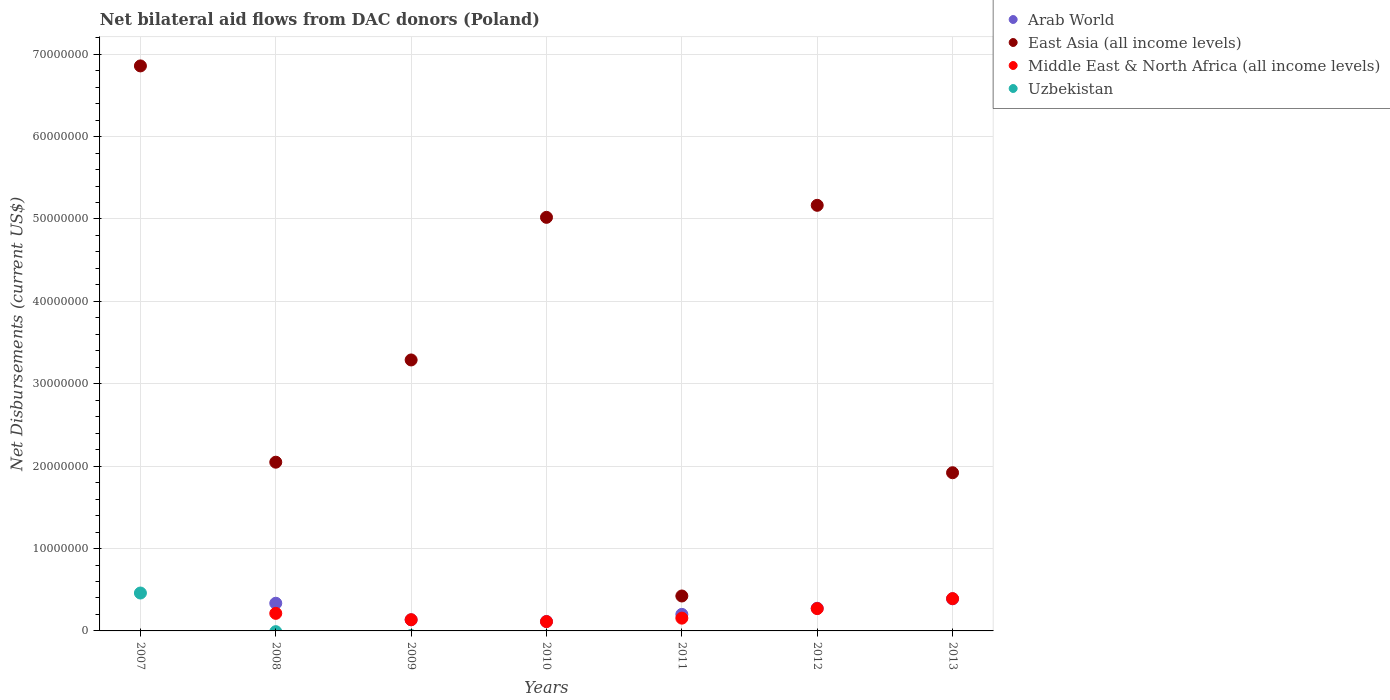How many different coloured dotlines are there?
Give a very brief answer. 4. What is the net bilateral aid flows in Arab World in 2010?
Your answer should be compact. 1.15e+06. Across all years, what is the maximum net bilateral aid flows in East Asia (all income levels)?
Give a very brief answer. 6.86e+07. Across all years, what is the minimum net bilateral aid flows in East Asia (all income levels)?
Make the answer very short. 4.24e+06. In which year was the net bilateral aid flows in Arab World maximum?
Make the answer very short. 2013. What is the total net bilateral aid flows in Middle East & North Africa (all income levels) in the graph?
Your answer should be very brief. 1.28e+07. What is the difference between the net bilateral aid flows in East Asia (all income levels) in 2008 and that in 2013?
Your response must be concise. 1.28e+06. What is the difference between the net bilateral aid flows in Arab World in 2012 and the net bilateral aid flows in Uzbekistan in 2008?
Offer a terse response. 2.75e+06. What is the average net bilateral aid flows in Middle East & North Africa (all income levels) per year?
Offer a very short reply. 1.83e+06. In the year 2007, what is the difference between the net bilateral aid flows in East Asia (all income levels) and net bilateral aid flows in Uzbekistan?
Make the answer very short. 6.40e+07. In how many years, is the net bilateral aid flows in Middle East & North Africa (all income levels) greater than 30000000 US$?
Provide a short and direct response. 0. What is the ratio of the net bilateral aid flows in East Asia (all income levels) in 2007 to that in 2010?
Your answer should be very brief. 1.37. Is the net bilateral aid flows in Middle East & North Africa (all income levels) in 2009 less than that in 2012?
Offer a terse response. Yes. What is the difference between the highest and the second highest net bilateral aid flows in Arab World?
Keep it short and to the point. 5.40e+05. What is the difference between the highest and the lowest net bilateral aid flows in Uzbekistan?
Your answer should be compact. 4.60e+06. Is it the case that in every year, the sum of the net bilateral aid flows in East Asia (all income levels) and net bilateral aid flows in Arab World  is greater than the sum of net bilateral aid flows in Middle East & North Africa (all income levels) and net bilateral aid flows in Uzbekistan?
Offer a terse response. Yes. Is the net bilateral aid flows in Arab World strictly less than the net bilateral aid flows in East Asia (all income levels) over the years?
Give a very brief answer. Yes. How many years are there in the graph?
Give a very brief answer. 7. What is the difference between two consecutive major ticks on the Y-axis?
Your answer should be very brief. 1.00e+07. Does the graph contain any zero values?
Provide a short and direct response. Yes. How many legend labels are there?
Make the answer very short. 4. What is the title of the graph?
Provide a short and direct response. Net bilateral aid flows from DAC donors (Poland). What is the label or title of the Y-axis?
Offer a terse response. Net Disbursements (current US$). What is the Net Disbursements (current US$) in East Asia (all income levels) in 2007?
Provide a short and direct response. 6.86e+07. What is the Net Disbursements (current US$) in Uzbekistan in 2007?
Ensure brevity in your answer.  4.60e+06. What is the Net Disbursements (current US$) in Arab World in 2008?
Your answer should be very brief. 3.36e+06. What is the Net Disbursements (current US$) of East Asia (all income levels) in 2008?
Make the answer very short. 2.05e+07. What is the Net Disbursements (current US$) of Middle East & North Africa (all income levels) in 2008?
Make the answer very short. 2.13e+06. What is the Net Disbursements (current US$) of Uzbekistan in 2008?
Give a very brief answer. 0. What is the Net Disbursements (current US$) of Arab World in 2009?
Offer a terse response. 1.35e+06. What is the Net Disbursements (current US$) in East Asia (all income levels) in 2009?
Your answer should be compact. 3.29e+07. What is the Net Disbursements (current US$) of Middle East & North Africa (all income levels) in 2009?
Give a very brief answer. 1.36e+06. What is the Net Disbursements (current US$) of Uzbekistan in 2009?
Your response must be concise. 0. What is the Net Disbursements (current US$) of Arab World in 2010?
Your answer should be compact. 1.15e+06. What is the Net Disbursements (current US$) in East Asia (all income levels) in 2010?
Offer a terse response. 5.02e+07. What is the Net Disbursements (current US$) in Middle East & North Africa (all income levels) in 2010?
Your response must be concise. 1.13e+06. What is the Net Disbursements (current US$) in Uzbekistan in 2010?
Keep it short and to the point. 0. What is the Net Disbursements (current US$) of Arab World in 2011?
Provide a short and direct response. 2.01e+06. What is the Net Disbursements (current US$) in East Asia (all income levels) in 2011?
Your answer should be compact. 4.24e+06. What is the Net Disbursements (current US$) of Middle East & North Africa (all income levels) in 2011?
Provide a succinct answer. 1.55e+06. What is the Net Disbursements (current US$) in Arab World in 2012?
Offer a very short reply. 2.75e+06. What is the Net Disbursements (current US$) of East Asia (all income levels) in 2012?
Keep it short and to the point. 5.17e+07. What is the Net Disbursements (current US$) of Middle East & North Africa (all income levels) in 2012?
Ensure brevity in your answer.  2.71e+06. What is the Net Disbursements (current US$) of Arab World in 2013?
Your answer should be compact. 3.90e+06. What is the Net Disbursements (current US$) of East Asia (all income levels) in 2013?
Your answer should be compact. 1.92e+07. What is the Net Disbursements (current US$) of Middle East & North Africa (all income levels) in 2013?
Your answer should be compact. 3.92e+06. What is the Net Disbursements (current US$) in Uzbekistan in 2013?
Your answer should be compact. 0. Across all years, what is the maximum Net Disbursements (current US$) in Arab World?
Your response must be concise. 3.90e+06. Across all years, what is the maximum Net Disbursements (current US$) in East Asia (all income levels)?
Offer a terse response. 6.86e+07. Across all years, what is the maximum Net Disbursements (current US$) in Middle East & North Africa (all income levels)?
Your answer should be compact. 3.92e+06. Across all years, what is the maximum Net Disbursements (current US$) of Uzbekistan?
Make the answer very short. 4.60e+06. Across all years, what is the minimum Net Disbursements (current US$) of Arab World?
Provide a succinct answer. 0. Across all years, what is the minimum Net Disbursements (current US$) of East Asia (all income levels)?
Your answer should be very brief. 4.24e+06. Across all years, what is the minimum Net Disbursements (current US$) in Middle East & North Africa (all income levels)?
Give a very brief answer. 0. Across all years, what is the minimum Net Disbursements (current US$) of Uzbekistan?
Keep it short and to the point. 0. What is the total Net Disbursements (current US$) in Arab World in the graph?
Your response must be concise. 1.45e+07. What is the total Net Disbursements (current US$) in East Asia (all income levels) in the graph?
Make the answer very short. 2.47e+08. What is the total Net Disbursements (current US$) in Middle East & North Africa (all income levels) in the graph?
Provide a short and direct response. 1.28e+07. What is the total Net Disbursements (current US$) in Uzbekistan in the graph?
Make the answer very short. 4.60e+06. What is the difference between the Net Disbursements (current US$) in East Asia (all income levels) in 2007 and that in 2008?
Ensure brevity in your answer.  4.81e+07. What is the difference between the Net Disbursements (current US$) in East Asia (all income levels) in 2007 and that in 2009?
Give a very brief answer. 3.57e+07. What is the difference between the Net Disbursements (current US$) in East Asia (all income levels) in 2007 and that in 2010?
Keep it short and to the point. 1.84e+07. What is the difference between the Net Disbursements (current US$) in East Asia (all income levels) in 2007 and that in 2011?
Your answer should be compact. 6.43e+07. What is the difference between the Net Disbursements (current US$) of East Asia (all income levels) in 2007 and that in 2012?
Your answer should be very brief. 1.69e+07. What is the difference between the Net Disbursements (current US$) in East Asia (all income levels) in 2007 and that in 2013?
Your answer should be compact. 4.94e+07. What is the difference between the Net Disbursements (current US$) of Arab World in 2008 and that in 2009?
Ensure brevity in your answer.  2.01e+06. What is the difference between the Net Disbursements (current US$) in East Asia (all income levels) in 2008 and that in 2009?
Your response must be concise. -1.24e+07. What is the difference between the Net Disbursements (current US$) in Middle East & North Africa (all income levels) in 2008 and that in 2009?
Your answer should be very brief. 7.70e+05. What is the difference between the Net Disbursements (current US$) of Arab World in 2008 and that in 2010?
Offer a terse response. 2.21e+06. What is the difference between the Net Disbursements (current US$) in East Asia (all income levels) in 2008 and that in 2010?
Keep it short and to the point. -2.97e+07. What is the difference between the Net Disbursements (current US$) of Arab World in 2008 and that in 2011?
Give a very brief answer. 1.35e+06. What is the difference between the Net Disbursements (current US$) of East Asia (all income levels) in 2008 and that in 2011?
Provide a succinct answer. 1.62e+07. What is the difference between the Net Disbursements (current US$) of Middle East & North Africa (all income levels) in 2008 and that in 2011?
Make the answer very short. 5.80e+05. What is the difference between the Net Disbursements (current US$) in Arab World in 2008 and that in 2012?
Provide a short and direct response. 6.10e+05. What is the difference between the Net Disbursements (current US$) in East Asia (all income levels) in 2008 and that in 2012?
Keep it short and to the point. -3.12e+07. What is the difference between the Net Disbursements (current US$) of Middle East & North Africa (all income levels) in 2008 and that in 2012?
Give a very brief answer. -5.80e+05. What is the difference between the Net Disbursements (current US$) of Arab World in 2008 and that in 2013?
Your answer should be compact. -5.40e+05. What is the difference between the Net Disbursements (current US$) in East Asia (all income levels) in 2008 and that in 2013?
Give a very brief answer. 1.28e+06. What is the difference between the Net Disbursements (current US$) in Middle East & North Africa (all income levels) in 2008 and that in 2013?
Provide a succinct answer. -1.79e+06. What is the difference between the Net Disbursements (current US$) in Arab World in 2009 and that in 2010?
Provide a succinct answer. 2.00e+05. What is the difference between the Net Disbursements (current US$) of East Asia (all income levels) in 2009 and that in 2010?
Give a very brief answer. -1.73e+07. What is the difference between the Net Disbursements (current US$) in Middle East & North Africa (all income levels) in 2009 and that in 2010?
Offer a very short reply. 2.30e+05. What is the difference between the Net Disbursements (current US$) in Arab World in 2009 and that in 2011?
Your response must be concise. -6.60e+05. What is the difference between the Net Disbursements (current US$) of East Asia (all income levels) in 2009 and that in 2011?
Make the answer very short. 2.86e+07. What is the difference between the Net Disbursements (current US$) in Arab World in 2009 and that in 2012?
Make the answer very short. -1.40e+06. What is the difference between the Net Disbursements (current US$) of East Asia (all income levels) in 2009 and that in 2012?
Your answer should be very brief. -1.88e+07. What is the difference between the Net Disbursements (current US$) in Middle East & North Africa (all income levels) in 2009 and that in 2012?
Offer a very short reply. -1.35e+06. What is the difference between the Net Disbursements (current US$) of Arab World in 2009 and that in 2013?
Your answer should be compact. -2.55e+06. What is the difference between the Net Disbursements (current US$) of East Asia (all income levels) in 2009 and that in 2013?
Your answer should be very brief. 1.37e+07. What is the difference between the Net Disbursements (current US$) in Middle East & North Africa (all income levels) in 2009 and that in 2013?
Provide a succinct answer. -2.56e+06. What is the difference between the Net Disbursements (current US$) in Arab World in 2010 and that in 2011?
Your response must be concise. -8.60e+05. What is the difference between the Net Disbursements (current US$) of East Asia (all income levels) in 2010 and that in 2011?
Your response must be concise. 4.60e+07. What is the difference between the Net Disbursements (current US$) in Middle East & North Africa (all income levels) in 2010 and that in 2011?
Give a very brief answer. -4.20e+05. What is the difference between the Net Disbursements (current US$) of Arab World in 2010 and that in 2012?
Your answer should be very brief. -1.60e+06. What is the difference between the Net Disbursements (current US$) of East Asia (all income levels) in 2010 and that in 2012?
Provide a succinct answer. -1.46e+06. What is the difference between the Net Disbursements (current US$) of Middle East & North Africa (all income levels) in 2010 and that in 2012?
Make the answer very short. -1.58e+06. What is the difference between the Net Disbursements (current US$) in Arab World in 2010 and that in 2013?
Keep it short and to the point. -2.75e+06. What is the difference between the Net Disbursements (current US$) of East Asia (all income levels) in 2010 and that in 2013?
Offer a terse response. 3.10e+07. What is the difference between the Net Disbursements (current US$) in Middle East & North Africa (all income levels) in 2010 and that in 2013?
Give a very brief answer. -2.79e+06. What is the difference between the Net Disbursements (current US$) of Arab World in 2011 and that in 2012?
Your answer should be compact. -7.40e+05. What is the difference between the Net Disbursements (current US$) in East Asia (all income levels) in 2011 and that in 2012?
Keep it short and to the point. -4.74e+07. What is the difference between the Net Disbursements (current US$) of Middle East & North Africa (all income levels) in 2011 and that in 2012?
Your answer should be very brief. -1.16e+06. What is the difference between the Net Disbursements (current US$) in Arab World in 2011 and that in 2013?
Offer a terse response. -1.89e+06. What is the difference between the Net Disbursements (current US$) in East Asia (all income levels) in 2011 and that in 2013?
Offer a very short reply. -1.50e+07. What is the difference between the Net Disbursements (current US$) in Middle East & North Africa (all income levels) in 2011 and that in 2013?
Ensure brevity in your answer.  -2.37e+06. What is the difference between the Net Disbursements (current US$) in Arab World in 2012 and that in 2013?
Keep it short and to the point. -1.15e+06. What is the difference between the Net Disbursements (current US$) of East Asia (all income levels) in 2012 and that in 2013?
Offer a terse response. 3.25e+07. What is the difference between the Net Disbursements (current US$) of Middle East & North Africa (all income levels) in 2012 and that in 2013?
Provide a short and direct response. -1.21e+06. What is the difference between the Net Disbursements (current US$) of East Asia (all income levels) in 2007 and the Net Disbursements (current US$) of Middle East & North Africa (all income levels) in 2008?
Make the answer very short. 6.64e+07. What is the difference between the Net Disbursements (current US$) of East Asia (all income levels) in 2007 and the Net Disbursements (current US$) of Middle East & North Africa (all income levels) in 2009?
Your answer should be very brief. 6.72e+07. What is the difference between the Net Disbursements (current US$) in East Asia (all income levels) in 2007 and the Net Disbursements (current US$) in Middle East & North Africa (all income levels) in 2010?
Ensure brevity in your answer.  6.74e+07. What is the difference between the Net Disbursements (current US$) of East Asia (all income levels) in 2007 and the Net Disbursements (current US$) of Middle East & North Africa (all income levels) in 2011?
Your response must be concise. 6.70e+07. What is the difference between the Net Disbursements (current US$) in East Asia (all income levels) in 2007 and the Net Disbursements (current US$) in Middle East & North Africa (all income levels) in 2012?
Make the answer very short. 6.59e+07. What is the difference between the Net Disbursements (current US$) in East Asia (all income levels) in 2007 and the Net Disbursements (current US$) in Middle East & North Africa (all income levels) in 2013?
Your response must be concise. 6.47e+07. What is the difference between the Net Disbursements (current US$) of Arab World in 2008 and the Net Disbursements (current US$) of East Asia (all income levels) in 2009?
Offer a terse response. -2.95e+07. What is the difference between the Net Disbursements (current US$) in East Asia (all income levels) in 2008 and the Net Disbursements (current US$) in Middle East & North Africa (all income levels) in 2009?
Provide a short and direct response. 1.91e+07. What is the difference between the Net Disbursements (current US$) in Arab World in 2008 and the Net Disbursements (current US$) in East Asia (all income levels) in 2010?
Ensure brevity in your answer.  -4.68e+07. What is the difference between the Net Disbursements (current US$) in Arab World in 2008 and the Net Disbursements (current US$) in Middle East & North Africa (all income levels) in 2010?
Keep it short and to the point. 2.23e+06. What is the difference between the Net Disbursements (current US$) of East Asia (all income levels) in 2008 and the Net Disbursements (current US$) of Middle East & North Africa (all income levels) in 2010?
Give a very brief answer. 1.94e+07. What is the difference between the Net Disbursements (current US$) of Arab World in 2008 and the Net Disbursements (current US$) of East Asia (all income levels) in 2011?
Provide a succinct answer. -8.80e+05. What is the difference between the Net Disbursements (current US$) in Arab World in 2008 and the Net Disbursements (current US$) in Middle East & North Africa (all income levels) in 2011?
Provide a short and direct response. 1.81e+06. What is the difference between the Net Disbursements (current US$) in East Asia (all income levels) in 2008 and the Net Disbursements (current US$) in Middle East & North Africa (all income levels) in 2011?
Ensure brevity in your answer.  1.89e+07. What is the difference between the Net Disbursements (current US$) in Arab World in 2008 and the Net Disbursements (current US$) in East Asia (all income levels) in 2012?
Give a very brief answer. -4.83e+07. What is the difference between the Net Disbursements (current US$) in Arab World in 2008 and the Net Disbursements (current US$) in Middle East & North Africa (all income levels) in 2012?
Give a very brief answer. 6.50e+05. What is the difference between the Net Disbursements (current US$) of East Asia (all income levels) in 2008 and the Net Disbursements (current US$) of Middle East & North Africa (all income levels) in 2012?
Offer a very short reply. 1.78e+07. What is the difference between the Net Disbursements (current US$) in Arab World in 2008 and the Net Disbursements (current US$) in East Asia (all income levels) in 2013?
Make the answer very short. -1.58e+07. What is the difference between the Net Disbursements (current US$) in Arab World in 2008 and the Net Disbursements (current US$) in Middle East & North Africa (all income levels) in 2013?
Offer a terse response. -5.60e+05. What is the difference between the Net Disbursements (current US$) of East Asia (all income levels) in 2008 and the Net Disbursements (current US$) of Middle East & North Africa (all income levels) in 2013?
Offer a very short reply. 1.66e+07. What is the difference between the Net Disbursements (current US$) in Arab World in 2009 and the Net Disbursements (current US$) in East Asia (all income levels) in 2010?
Ensure brevity in your answer.  -4.88e+07. What is the difference between the Net Disbursements (current US$) in East Asia (all income levels) in 2009 and the Net Disbursements (current US$) in Middle East & North Africa (all income levels) in 2010?
Your response must be concise. 3.18e+07. What is the difference between the Net Disbursements (current US$) of Arab World in 2009 and the Net Disbursements (current US$) of East Asia (all income levels) in 2011?
Your answer should be very brief. -2.89e+06. What is the difference between the Net Disbursements (current US$) in Arab World in 2009 and the Net Disbursements (current US$) in Middle East & North Africa (all income levels) in 2011?
Make the answer very short. -2.00e+05. What is the difference between the Net Disbursements (current US$) in East Asia (all income levels) in 2009 and the Net Disbursements (current US$) in Middle East & North Africa (all income levels) in 2011?
Give a very brief answer. 3.13e+07. What is the difference between the Net Disbursements (current US$) in Arab World in 2009 and the Net Disbursements (current US$) in East Asia (all income levels) in 2012?
Provide a succinct answer. -5.03e+07. What is the difference between the Net Disbursements (current US$) in Arab World in 2009 and the Net Disbursements (current US$) in Middle East & North Africa (all income levels) in 2012?
Offer a terse response. -1.36e+06. What is the difference between the Net Disbursements (current US$) of East Asia (all income levels) in 2009 and the Net Disbursements (current US$) of Middle East & North Africa (all income levels) in 2012?
Provide a succinct answer. 3.02e+07. What is the difference between the Net Disbursements (current US$) of Arab World in 2009 and the Net Disbursements (current US$) of East Asia (all income levels) in 2013?
Provide a short and direct response. -1.78e+07. What is the difference between the Net Disbursements (current US$) in Arab World in 2009 and the Net Disbursements (current US$) in Middle East & North Africa (all income levels) in 2013?
Provide a succinct answer. -2.57e+06. What is the difference between the Net Disbursements (current US$) of East Asia (all income levels) in 2009 and the Net Disbursements (current US$) of Middle East & North Africa (all income levels) in 2013?
Provide a succinct answer. 2.90e+07. What is the difference between the Net Disbursements (current US$) of Arab World in 2010 and the Net Disbursements (current US$) of East Asia (all income levels) in 2011?
Provide a succinct answer. -3.09e+06. What is the difference between the Net Disbursements (current US$) of Arab World in 2010 and the Net Disbursements (current US$) of Middle East & North Africa (all income levels) in 2011?
Provide a short and direct response. -4.00e+05. What is the difference between the Net Disbursements (current US$) of East Asia (all income levels) in 2010 and the Net Disbursements (current US$) of Middle East & North Africa (all income levels) in 2011?
Give a very brief answer. 4.86e+07. What is the difference between the Net Disbursements (current US$) in Arab World in 2010 and the Net Disbursements (current US$) in East Asia (all income levels) in 2012?
Provide a short and direct response. -5.05e+07. What is the difference between the Net Disbursements (current US$) of Arab World in 2010 and the Net Disbursements (current US$) of Middle East & North Africa (all income levels) in 2012?
Provide a short and direct response. -1.56e+06. What is the difference between the Net Disbursements (current US$) in East Asia (all income levels) in 2010 and the Net Disbursements (current US$) in Middle East & North Africa (all income levels) in 2012?
Give a very brief answer. 4.75e+07. What is the difference between the Net Disbursements (current US$) of Arab World in 2010 and the Net Disbursements (current US$) of East Asia (all income levels) in 2013?
Provide a short and direct response. -1.80e+07. What is the difference between the Net Disbursements (current US$) in Arab World in 2010 and the Net Disbursements (current US$) in Middle East & North Africa (all income levels) in 2013?
Offer a very short reply. -2.77e+06. What is the difference between the Net Disbursements (current US$) in East Asia (all income levels) in 2010 and the Net Disbursements (current US$) in Middle East & North Africa (all income levels) in 2013?
Give a very brief answer. 4.63e+07. What is the difference between the Net Disbursements (current US$) in Arab World in 2011 and the Net Disbursements (current US$) in East Asia (all income levels) in 2012?
Ensure brevity in your answer.  -4.96e+07. What is the difference between the Net Disbursements (current US$) of Arab World in 2011 and the Net Disbursements (current US$) of Middle East & North Africa (all income levels) in 2012?
Offer a terse response. -7.00e+05. What is the difference between the Net Disbursements (current US$) of East Asia (all income levels) in 2011 and the Net Disbursements (current US$) of Middle East & North Africa (all income levels) in 2012?
Ensure brevity in your answer.  1.53e+06. What is the difference between the Net Disbursements (current US$) of Arab World in 2011 and the Net Disbursements (current US$) of East Asia (all income levels) in 2013?
Provide a succinct answer. -1.72e+07. What is the difference between the Net Disbursements (current US$) in Arab World in 2011 and the Net Disbursements (current US$) in Middle East & North Africa (all income levels) in 2013?
Your answer should be very brief. -1.91e+06. What is the difference between the Net Disbursements (current US$) of Arab World in 2012 and the Net Disbursements (current US$) of East Asia (all income levels) in 2013?
Provide a succinct answer. -1.64e+07. What is the difference between the Net Disbursements (current US$) of Arab World in 2012 and the Net Disbursements (current US$) of Middle East & North Africa (all income levels) in 2013?
Give a very brief answer. -1.17e+06. What is the difference between the Net Disbursements (current US$) in East Asia (all income levels) in 2012 and the Net Disbursements (current US$) in Middle East & North Africa (all income levels) in 2013?
Give a very brief answer. 4.77e+07. What is the average Net Disbursements (current US$) of Arab World per year?
Make the answer very short. 2.07e+06. What is the average Net Disbursements (current US$) in East Asia (all income levels) per year?
Offer a very short reply. 3.53e+07. What is the average Net Disbursements (current US$) in Middle East & North Africa (all income levels) per year?
Give a very brief answer. 1.83e+06. What is the average Net Disbursements (current US$) of Uzbekistan per year?
Give a very brief answer. 6.57e+05. In the year 2007, what is the difference between the Net Disbursements (current US$) of East Asia (all income levels) and Net Disbursements (current US$) of Uzbekistan?
Offer a terse response. 6.40e+07. In the year 2008, what is the difference between the Net Disbursements (current US$) in Arab World and Net Disbursements (current US$) in East Asia (all income levels)?
Your answer should be very brief. -1.71e+07. In the year 2008, what is the difference between the Net Disbursements (current US$) in Arab World and Net Disbursements (current US$) in Middle East & North Africa (all income levels)?
Ensure brevity in your answer.  1.23e+06. In the year 2008, what is the difference between the Net Disbursements (current US$) in East Asia (all income levels) and Net Disbursements (current US$) in Middle East & North Africa (all income levels)?
Offer a very short reply. 1.84e+07. In the year 2009, what is the difference between the Net Disbursements (current US$) of Arab World and Net Disbursements (current US$) of East Asia (all income levels)?
Give a very brief answer. -3.15e+07. In the year 2009, what is the difference between the Net Disbursements (current US$) of East Asia (all income levels) and Net Disbursements (current US$) of Middle East & North Africa (all income levels)?
Give a very brief answer. 3.15e+07. In the year 2010, what is the difference between the Net Disbursements (current US$) in Arab World and Net Disbursements (current US$) in East Asia (all income levels)?
Offer a terse response. -4.90e+07. In the year 2010, what is the difference between the Net Disbursements (current US$) of East Asia (all income levels) and Net Disbursements (current US$) of Middle East & North Africa (all income levels)?
Provide a succinct answer. 4.91e+07. In the year 2011, what is the difference between the Net Disbursements (current US$) in Arab World and Net Disbursements (current US$) in East Asia (all income levels)?
Offer a terse response. -2.23e+06. In the year 2011, what is the difference between the Net Disbursements (current US$) in East Asia (all income levels) and Net Disbursements (current US$) in Middle East & North Africa (all income levels)?
Provide a succinct answer. 2.69e+06. In the year 2012, what is the difference between the Net Disbursements (current US$) in Arab World and Net Disbursements (current US$) in East Asia (all income levels)?
Keep it short and to the point. -4.89e+07. In the year 2012, what is the difference between the Net Disbursements (current US$) of Arab World and Net Disbursements (current US$) of Middle East & North Africa (all income levels)?
Offer a terse response. 4.00e+04. In the year 2012, what is the difference between the Net Disbursements (current US$) in East Asia (all income levels) and Net Disbursements (current US$) in Middle East & North Africa (all income levels)?
Your answer should be compact. 4.90e+07. In the year 2013, what is the difference between the Net Disbursements (current US$) in Arab World and Net Disbursements (current US$) in East Asia (all income levels)?
Make the answer very short. -1.53e+07. In the year 2013, what is the difference between the Net Disbursements (current US$) in Arab World and Net Disbursements (current US$) in Middle East & North Africa (all income levels)?
Give a very brief answer. -2.00e+04. In the year 2013, what is the difference between the Net Disbursements (current US$) of East Asia (all income levels) and Net Disbursements (current US$) of Middle East & North Africa (all income levels)?
Make the answer very short. 1.53e+07. What is the ratio of the Net Disbursements (current US$) in East Asia (all income levels) in 2007 to that in 2008?
Provide a succinct answer. 3.35. What is the ratio of the Net Disbursements (current US$) in East Asia (all income levels) in 2007 to that in 2009?
Your answer should be compact. 2.09. What is the ratio of the Net Disbursements (current US$) in East Asia (all income levels) in 2007 to that in 2010?
Make the answer very short. 1.37. What is the ratio of the Net Disbursements (current US$) in East Asia (all income levels) in 2007 to that in 2011?
Provide a succinct answer. 16.17. What is the ratio of the Net Disbursements (current US$) in East Asia (all income levels) in 2007 to that in 2012?
Offer a very short reply. 1.33. What is the ratio of the Net Disbursements (current US$) of East Asia (all income levels) in 2007 to that in 2013?
Keep it short and to the point. 3.57. What is the ratio of the Net Disbursements (current US$) of Arab World in 2008 to that in 2009?
Your answer should be compact. 2.49. What is the ratio of the Net Disbursements (current US$) of East Asia (all income levels) in 2008 to that in 2009?
Keep it short and to the point. 0.62. What is the ratio of the Net Disbursements (current US$) of Middle East & North Africa (all income levels) in 2008 to that in 2009?
Provide a succinct answer. 1.57. What is the ratio of the Net Disbursements (current US$) in Arab World in 2008 to that in 2010?
Offer a very short reply. 2.92. What is the ratio of the Net Disbursements (current US$) in East Asia (all income levels) in 2008 to that in 2010?
Offer a terse response. 0.41. What is the ratio of the Net Disbursements (current US$) of Middle East & North Africa (all income levels) in 2008 to that in 2010?
Offer a very short reply. 1.89. What is the ratio of the Net Disbursements (current US$) in Arab World in 2008 to that in 2011?
Your response must be concise. 1.67. What is the ratio of the Net Disbursements (current US$) in East Asia (all income levels) in 2008 to that in 2011?
Make the answer very short. 4.83. What is the ratio of the Net Disbursements (current US$) of Middle East & North Africa (all income levels) in 2008 to that in 2011?
Ensure brevity in your answer.  1.37. What is the ratio of the Net Disbursements (current US$) in Arab World in 2008 to that in 2012?
Provide a succinct answer. 1.22. What is the ratio of the Net Disbursements (current US$) of East Asia (all income levels) in 2008 to that in 2012?
Keep it short and to the point. 0.4. What is the ratio of the Net Disbursements (current US$) of Middle East & North Africa (all income levels) in 2008 to that in 2012?
Offer a terse response. 0.79. What is the ratio of the Net Disbursements (current US$) in Arab World in 2008 to that in 2013?
Your answer should be very brief. 0.86. What is the ratio of the Net Disbursements (current US$) in East Asia (all income levels) in 2008 to that in 2013?
Make the answer very short. 1.07. What is the ratio of the Net Disbursements (current US$) in Middle East & North Africa (all income levels) in 2008 to that in 2013?
Give a very brief answer. 0.54. What is the ratio of the Net Disbursements (current US$) of Arab World in 2009 to that in 2010?
Your answer should be very brief. 1.17. What is the ratio of the Net Disbursements (current US$) in East Asia (all income levels) in 2009 to that in 2010?
Ensure brevity in your answer.  0.66. What is the ratio of the Net Disbursements (current US$) in Middle East & North Africa (all income levels) in 2009 to that in 2010?
Ensure brevity in your answer.  1.2. What is the ratio of the Net Disbursements (current US$) in Arab World in 2009 to that in 2011?
Make the answer very short. 0.67. What is the ratio of the Net Disbursements (current US$) in East Asia (all income levels) in 2009 to that in 2011?
Give a very brief answer. 7.76. What is the ratio of the Net Disbursements (current US$) in Middle East & North Africa (all income levels) in 2009 to that in 2011?
Your response must be concise. 0.88. What is the ratio of the Net Disbursements (current US$) of Arab World in 2009 to that in 2012?
Your answer should be very brief. 0.49. What is the ratio of the Net Disbursements (current US$) in East Asia (all income levels) in 2009 to that in 2012?
Offer a very short reply. 0.64. What is the ratio of the Net Disbursements (current US$) of Middle East & North Africa (all income levels) in 2009 to that in 2012?
Your answer should be very brief. 0.5. What is the ratio of the Net Disbursements (current US$) of Arab World in 2009 to that in 2013?
Give a very brief answer. 0.35. What is the ratio of the Net Disbursements (current US$) in East Asia (all income levels) in 2009 to that in 2013?
Your answer should be compact. 1.71. What is the ratio of the Net Disbursements (current US$) of Middle East & North Africa (all income levels) in 2009 to that in 2013?
Ensure brevity in your answer.  0.35. What is the ratio of the Net Disbursements (current US$) of Arab World in 2010 to that in 2011?
Keep it short and to the point. 0.57. What is the ratio of the Net Disbursements (current US$) of East Asia (all income levels) in 2010 to that in 2011?
Your answer should be compact. 11.84. What is the ratio of the Net Disbursements (current US$) of Middle East & North Africa (all income levels) in 2010 to that in 2011?
Provide a short and direct response. 0.73. What is the ratio of the Net Disbursements (current US$) of Arab World in 2010 to that in 2012?
Your response must be concise. 0.42. What is the ratio of the Net Disbursements (current US$) of East Asia (all income levels) in 2010 to that in 2012?
Provide a succinct answer. 0.97. What is the ratio of the Net Disbursements (current US$) in Middle East & North Africa (all income levels) in 2010 to that in 2012?
Make the answer very short. 0.42. What is the ratio of the Net Disbursements (current US$) of Arab World in 2010 to that in 2013?
Your answer should be very brief. 0.29. What is the ratio of the Net Disbursements (current US$) of East Asia (all income levels) in 2010 to that in 2013?
Give a very brief answer. 2.61. What is the ratio of the Net Disbursements (current US$) in Middle East & North Africa (all income levels) in 2010 to that in 2013?
Provide a succinct answer. 0.29. What is the ratio of the Net Disbursements (current US$) in Arab World in 2011 to that in 2012?
Your response must be concise. 0.73. What is the ratio of the Net Disbursements (current US$) in East Asia (all income levels) in 2011 to that in 2012?
Ensure brevity in your answer.  0.08. What is the ratio of the Net Disbursements (current US$) in Middle East & North Africa (all income levels) in 2011 to that in 2012?
Ensure brevity in your answer.  0.57. What is the ratio of the Net Disbursements (current US$) of Arab World in 2011 to that in 2013?
Your answer should be compact. 0.52. What is the ratio of the Net Disbursements (current US$) in East Asia (all income levels) in 2011 to that in 2013?
Keep it short and to the point. 0.22. What is the ratio of the Net Disbursements (current US$) of Middle East & North Africa (all income levels) in 2011 to that in 2013?
Ensure brevity in your answer.  0.4. What is the ratio of the Net Disbursements (current US$) in Arab World in 2012 to that in 2013?
Offer a terse response. 0.71. What is the ratio of the Net Disbursements (current US$) of East Asia (all income levels) in 2012 to that in 2013?
Ensure brevity in your answer.  2.69. What is the ratio of the Net Disbursements (current US$) in Middle East & North Africa (all income levels) in 2012 to that in 2013?
Offer a terse response. 0.69. What is the difference between the highest and the second highest Net Disbursements (current US$) of Arab World?
Ensure brevity in your answer.  5.40e+05. What is the difference between the highest and the second highest Net Disbursements (current US$) of East Asia (all income levels)?
Your response must be concise. 1.69e+07. What is the difference between the highest and the second highest Net Disbursements (current US$) in Middle East & North Africa (all income levels)?
Offer a terse response. 1.21e+06. What is the difference between the highest and the lowest Net Disbursements (current US$) of Arab World?
Keep it short and to the point. 3.90e+06. What is the difference between the highest and the lowest Net Disbursements (current US$) of East Asia (all income levels)?
Your response must be concise. 6.43e+07. What is the difference between the highest and the lowest Net Disbursements (current US$) in Middle East & North Africa (all income levels)?
Ensure brevity in your answer.  3.92e+06. What is the difference between the highest and the lowest Net Disbursements (current US$) in Uzbekistan?
Make the answer very short. 4.60e+06. 